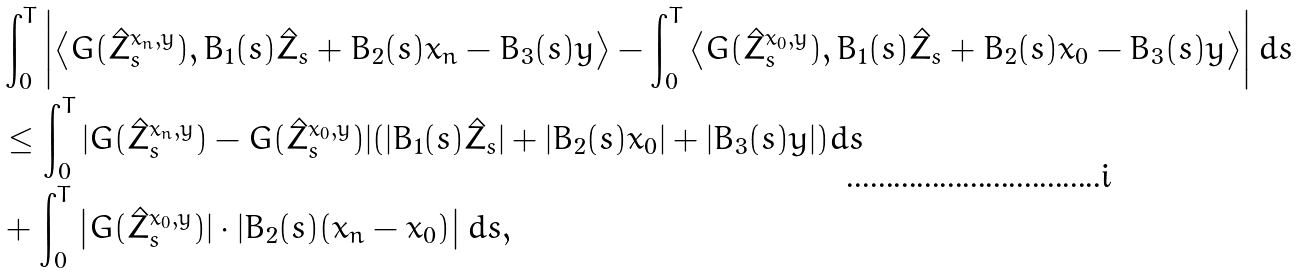Convert formula to latex. <formula><loc_0><loc_0><loc_500><loc_500>& \int _ { 0 } ^ { T } \left | \left \langle G ( \hat { Z } ^ { x _ { n } , y } _ { s } ) , B _ { 1 } ( s ) \hat { Z } _ { s } + B _ { 2 } ( s ) x _ { n } - B _ { 3 } ( s ) y \right \rangle - \int _ { 0 } ^ { T } \left \langle G ( \hat { Z } ^ { x _ { 0 } , y } _ { s } ) , B _ { 1 } ( s ) \hat { Z } _ { s } + B _ { 2 } ( s ) x _ { 0 } - B _ { 3 } ( s ) y \right \rangle \right | d s \\ & \leq \int _ { 0 } ^ { T } | G ( \hat { Z } ^ { x _ { n } , y } _ { s } ) - G ( \hat { Z } ^ { x _ { 0 } , y } _ { s } ) | ( | B _ { 1 } ( s ) \hat { Z } _ { s } | + | B _ { 2 } ( s ) x _ { 0 } | + | B _ { 3 } ( s ) y | ) d s \\ & + \int _ { 0 } ^ { T } \left | G ( \hat { Z } ^ { x _ { 0 } , y } _ { s } ) | \cdot | B _ { 2 } ( s ) ( x _ { n } - x _ { 0 } ) \right | d s ,</formula> 